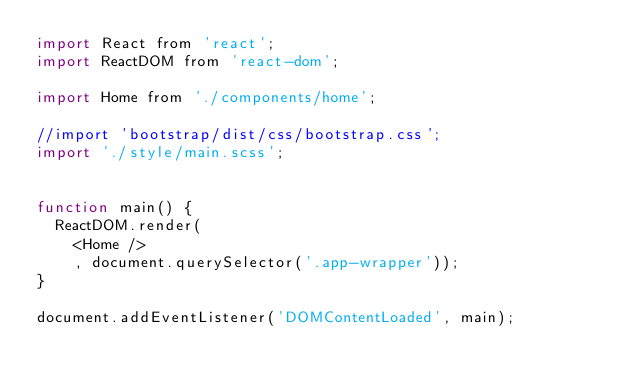<code> <loc_0><loc_0><loc_500><loc_500><_JavaScript_>import React from 'react';
import ReactDOM from 'react-dom';

import Home from './components/home';

//import 'bootstrap/dist/css/bootstrap.css';
import './style/main.scss';


function main() {
  ReactDOM.render(
    <Home />
    , document.querySelector('.app-wrapper'));
}

document.addEventListener('DOMContentLoaded', main);
</code> 